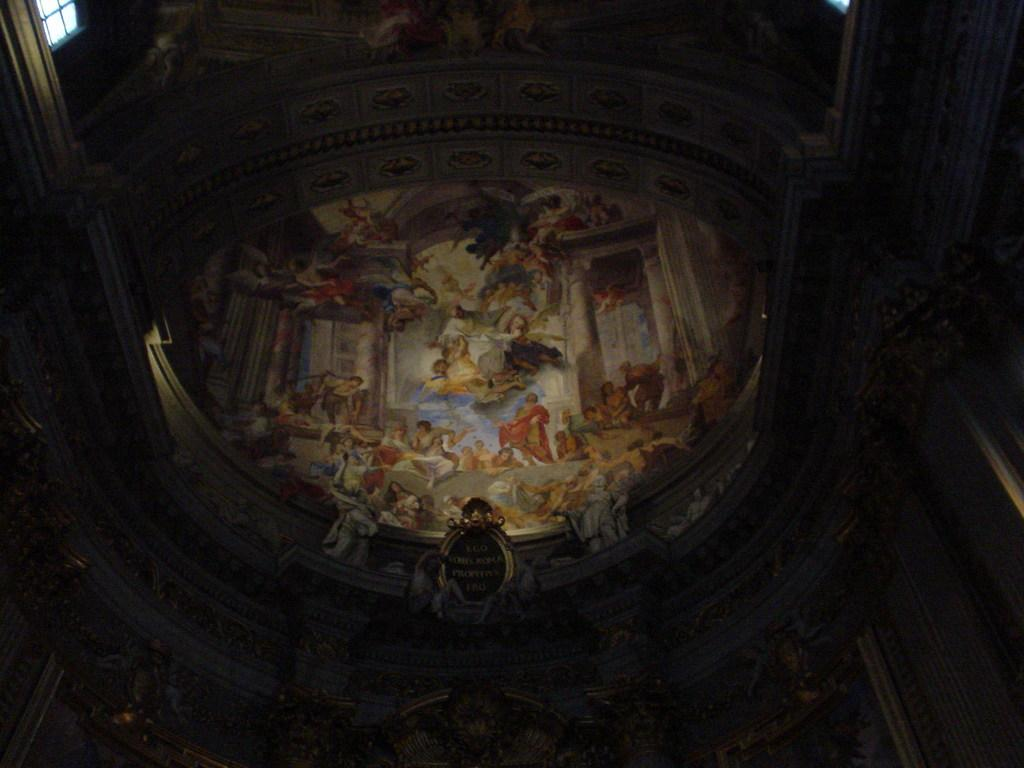What is depicted on the interior walls of the building in the image? There are images on the interior walls of the building in the image. What type of country is shown on the shirt in the image? There is no shirt present in the image; it only features images on the interior walls of a building. 